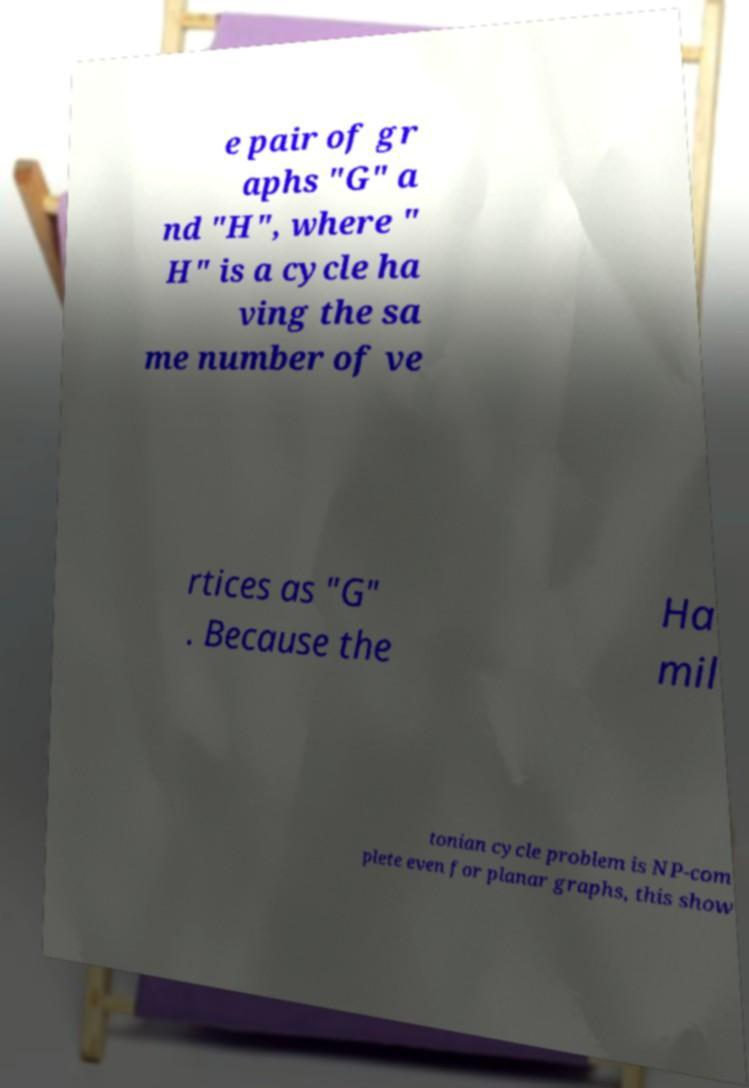There's text embedded in this image that I need extracted. Can you transcribe it verbatim? e pair of gr aphs "G" a nd "H", where " H" is a cycle ha ving the sa me number of ve rtices as "G" . Because the Ha mil tonian cycle problem is NP-com plete even for planar graphs, this show 